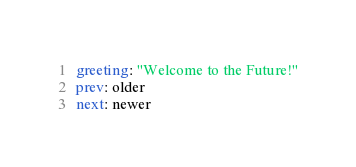Convert code to text. <code><loc_0><loc_0><loc_500><loc_500><_YAML_>greeting: "Welcome to the Future!"
prev: older
next: newer
</code> 